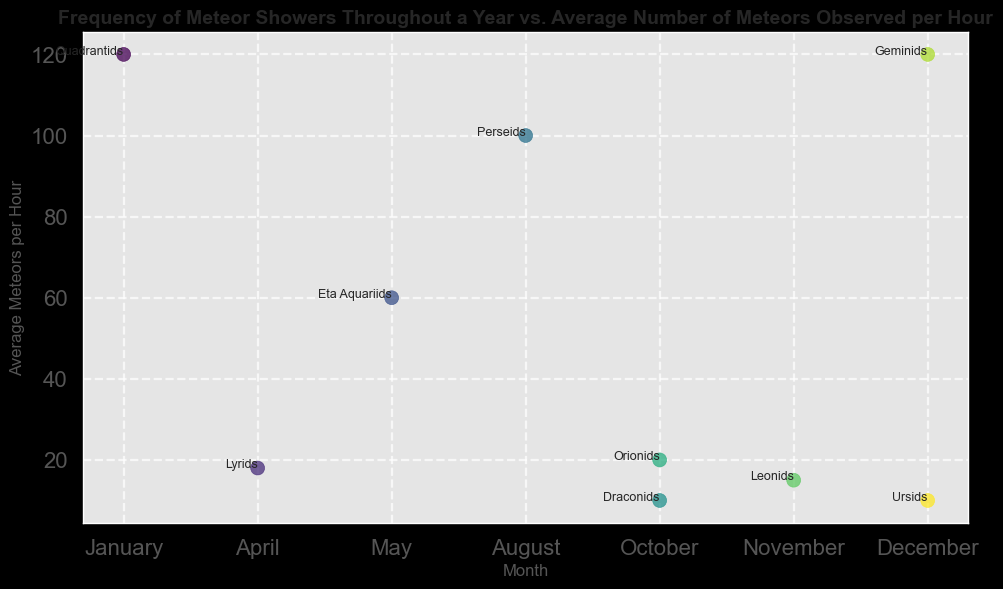Which meteor shower has the highest average number of meteors per hour? To find this, look for the meteor shower with the highest y-axis value. The Geminids and Quadrantids both have values at the top of the y-axis with 120 meteors per hour.
Answer: Geminids and Quadrantids Which month features the most diverse range of average meteors per hour? Check for the month(s) with multiple data points that have varying y-axis values. October has Draconids (10) and Orionids (20) with different values.
Answer: October How many meteor showers have an average of 20 or fewer meteors per hour? Identify all data points on or below 20 on the y-axis. These include Lyrids (18), Draconids (10), Orionids (20), Leonids (15), and Ursids (10). Count them.
Answer: 5 Which meteor shower occurring in October has the higher average meteors per hour? Identify the meteor showers in October and compare their y-axis values. Orionids (20) is higher than Draconids (10).
Answer: Orionids What is the average number of meteors observed per hour in December? Identify the values for December: Geminids (120) and Ursids (10). Calculate their average (120 + 10) / 2 = 65.
Answer: 65 Comparing July and November, which month has a higher average number of meteors per hour? Since there is no data for July, check November. Leonids in November has 15 meteors per hour. Hence, November.
Answer: November Are there more meteor showers with an average of 10 meteors per hour than those with 15? Identify meteor showers with exactly 10 meteors (Draconids, Ursids) and those with exactly 15 meteors (Leonids). Compare their counts.
Answer: No Which meteor shower has the lowest average number of meteors per hour, and in which month does it occur? Find the lowest y-axis value and corresponding meteor shower and month. Draconids and Ursids both have the lowest value (10) and occur in October and December respectively.
Answer: Draconids in October, Ursids in December How many meteor showers are observed in the first quarter of the year, and what are their average numbers of meteors per hour? Identify the months Jan, Feb, and Mar, checking for data points. Only Quadrantids in January are there, with 120 meteors per hour.
Answer: 1, Quadrantids at 120 What is the sum of the average meteors per hour for all meteor showers occurring in April and August? Identify the values for April (Lyrids, 18) and August (Perseids, 100). Sum these values: 18 + 100 = 118.
Answer: 118 